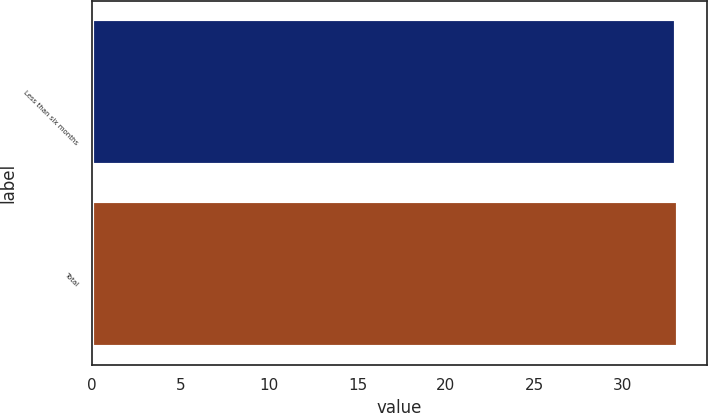Convert chart. <chart><loc_0><loc_0><loc_500><loc_500><bar_chart><fcel>Less than six months<fcel>Total<nl><fcel>33<fcel>33.1<nl></chart> 